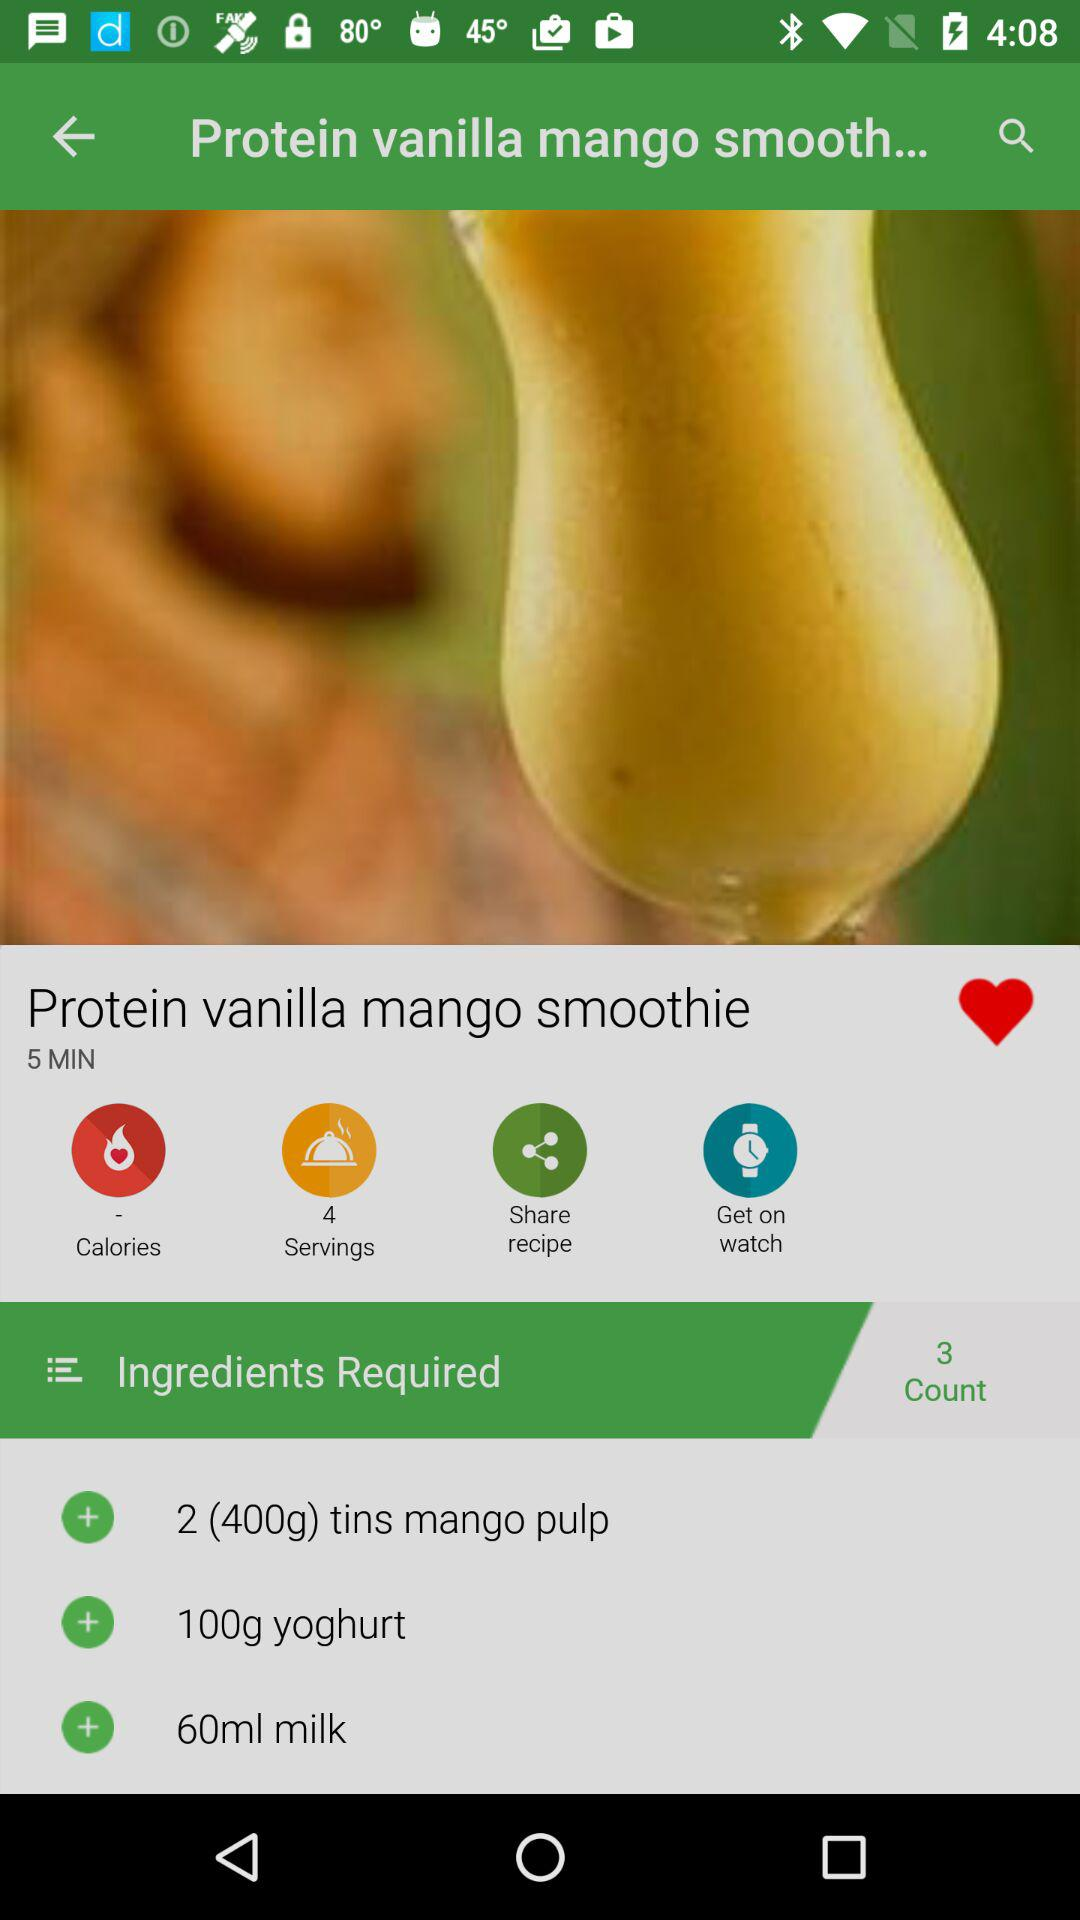How much yoghurt is required? The required amount of yoghurt is 100 g. 